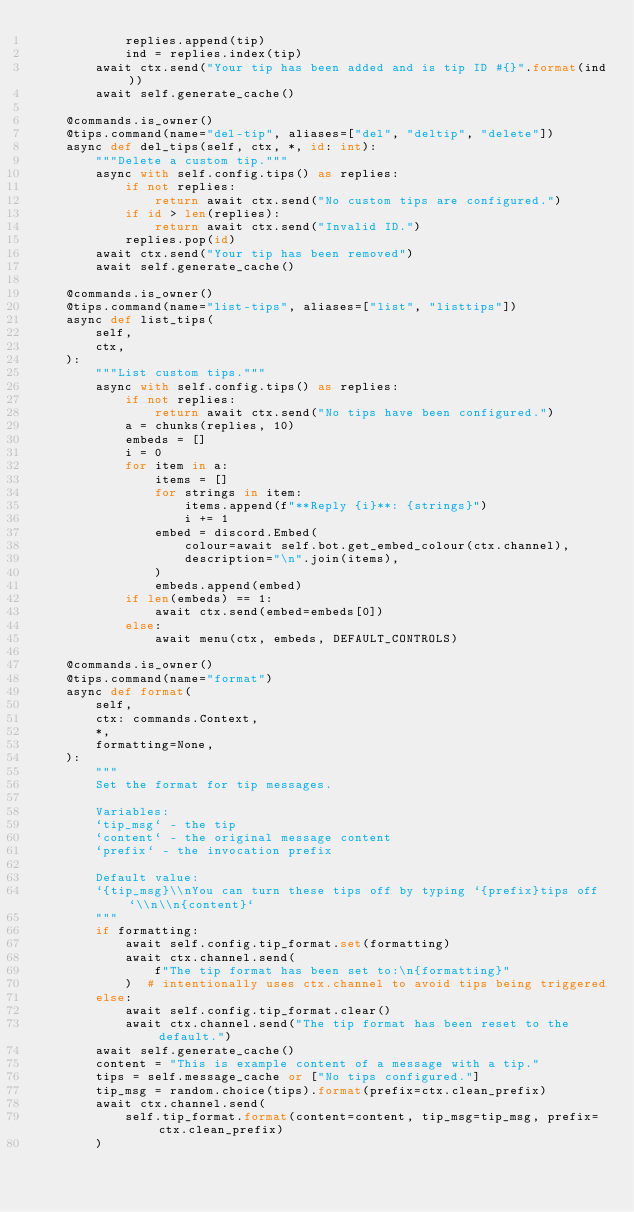Convert code to text. <code><loc_0><loc_0><loc_500><loc_500><_Python_>            replies.append(tip)
            ind = replies.index(tip)
        await ctx.send("Your tip has been added and is tip ID #{}".format(ind))
        await self.generate_cache()

    @commands.is_owner()
    @tips.command(name="del-tip", aliases=["del", "deltip", "delete"])
    async def del_tips(self, ctx, *, id: int):
        """Delete a custom tip."""
        async with self.config.tips() as replies:
            if not replies:
                return await ctx.send("No custom tips are configured.")
            if id > len(replies):
                return await ctx.send("Invalid ID.")
            replies.pop(id)
        await ctx.send("Your tip has been removed")
        await self.generate_cache()

    @commands.is_owner()
    @tips.command(name="list-tips", aliases=["list", "listtips"])
    async def list_tips(
        self,
        ctx,
    ):
        """List custom tips."""
        async with self.config.tips() as replies:
            if not replies:
                return await ctx.send("No tips have been configured.")
            a = chunks(replies, 10)
            embeds = []
            i = 0
            for item in a:
                items = []
                for strings in item:
                    items.append(f"**Reply {i}**: {strings}")
                    i += 1
                embed = discord.Embed(
                    colour=await self.bot.get_embed_colour(ctx.channel),
                    description="\n".join(items),
                )
                embeds.append(embed)
            if len(embeds) == 1:
                await ctx.send(embed=embeds[0])
            else:
                await menu(ctx, embeds, DEFAULT_CONTROLS)

    @commands.is_owner()
    @tips.command(name="format")
    async def format(
        self,
        ctx: commands.Context,
        *,
        formatting=None,
    ):
        """
        Set the format for tip messages.

        Variables:
        `tip_msg` - the tip
        `content` - the original message content
        `prefix` - the invocation prefix

        Default value:
        `{tip_msg}\\nYou can turn these tips off by typing `{prefix}tips off`\\n\\n{content}`
        """
        if formatting:
            await self.config.tip_format.set(formatting)
            await ctx.channel.send(
                f"The tip format has been set to:\n{formatting}"
            )  # intentionally uses ctx.channel to avoid tips being triggered
        else:
            await self.config.tip_format.clear()
            await ctx.channel.send("The tip format has been reset to the default.")
        await self.generate_cache()
        content = "This is example content of a message with a tip."
        tips = self.message_cache or ["No tips configured."]
        tip_msg = random.choice(tips).format(prefix=ctx.clean_prefix)
        await ctx.channel.send(
            self.tip_format.format(content=content, tip_msg=tip_msg, prefix=ctx.clean_prefix)
        )
</code> 